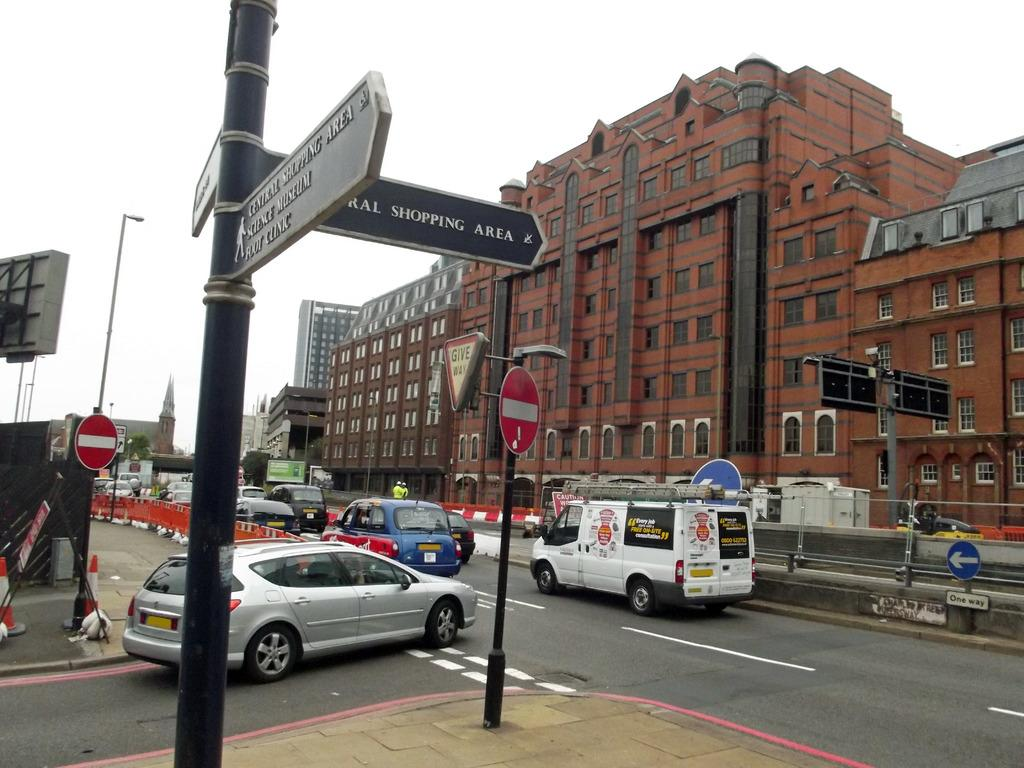What can be seen in the image that is used for transportation? There are vehicles in the image. What is attached to a pole in the image? There are boards attached to a pole in the image. What can be seen in the background of the image that provides illumination? There are light poles in the background of the image. What is visible in the background of the image that indicates human presence? There are buildings in the background of the image. What is the color of the sky in the image? The sky is white in color. How many bananas are hanging from the light poles in the image? There are no bananas present in the image; the light poles are not associated with any fruit. What type of silver object can be seen in the image? There is no silver object present in the image. 